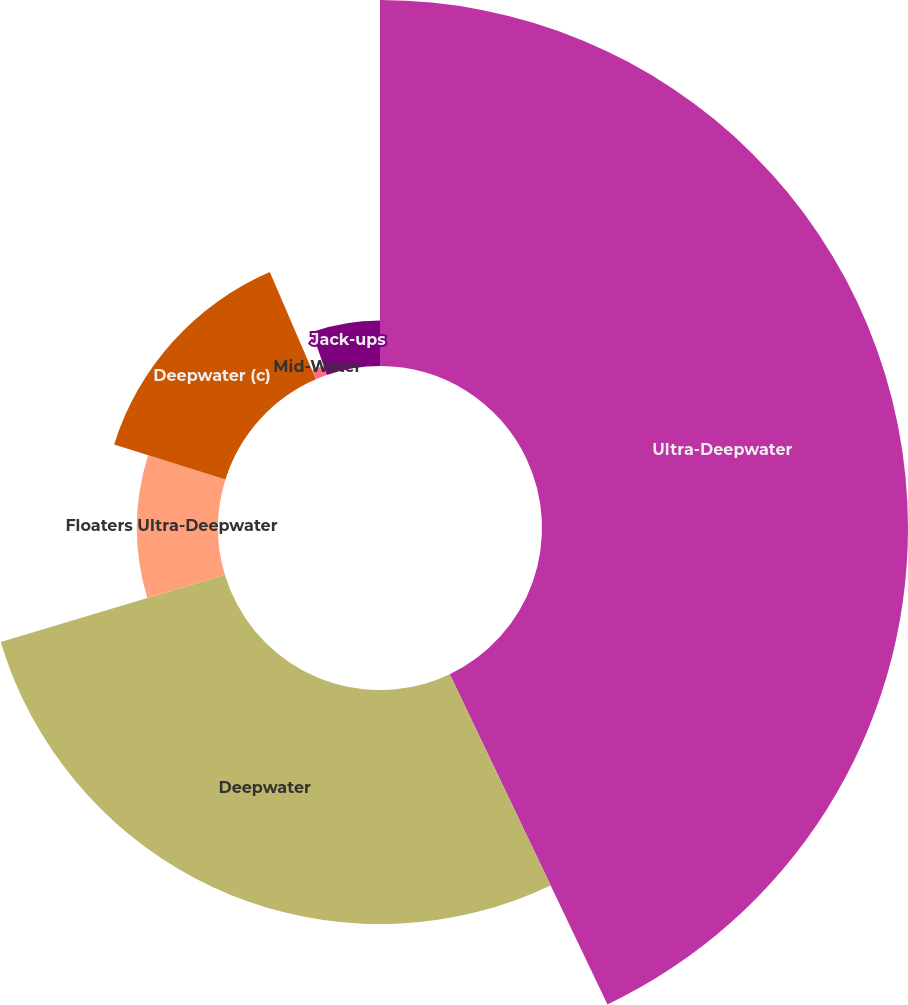Convert chart to OTSL. <chart><loc_0><loc_0><loc_500><loc_500><pie_chart><fcel>Ultra-Deepwater<fcel>Deepwater<fcel>Floaters Ultra-Deepwater<fcel>Deepwater (c)<fcel>Mid-Water<fcel>Jack-ups<nl><fcel>42.91%<fcel>27.44%<fcel>9.5%<fcel>13.68%<fcel>1.15%<fcel>5.32%<nl></chart> 